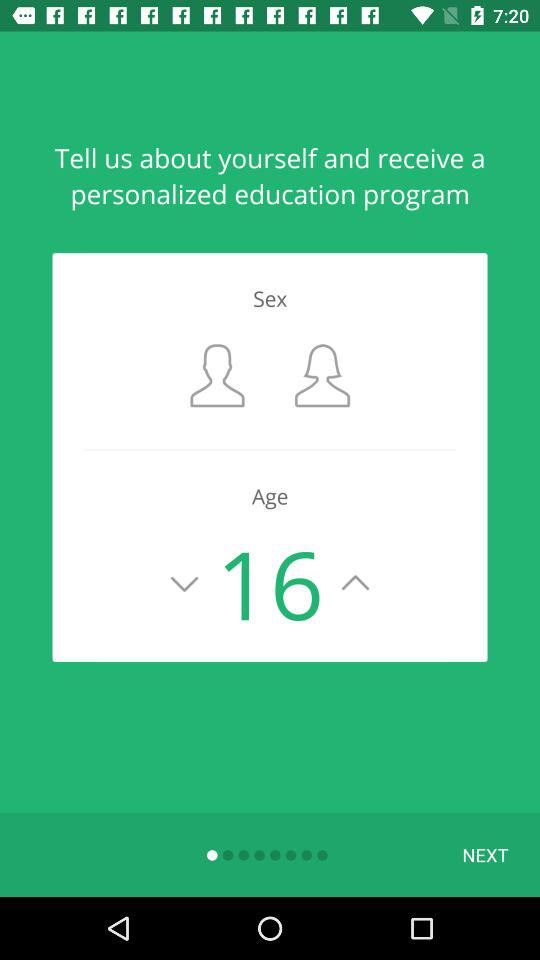Which sex is selected?
When the provided information is insufficient, respond with <no answer>. <no answer> 